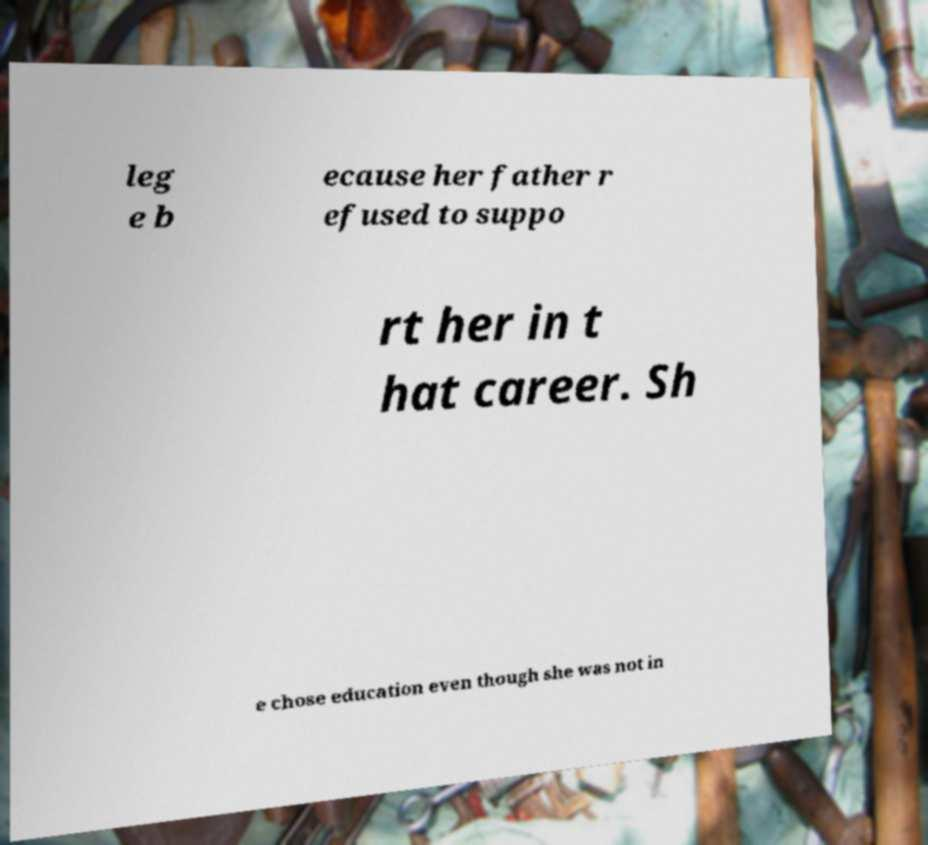Could you assist in decoding the text presented in this image and type it out clearly? leg e b ecause her father r efused to suppo rt her in t hat career. Sh e chose education even though she was not in 